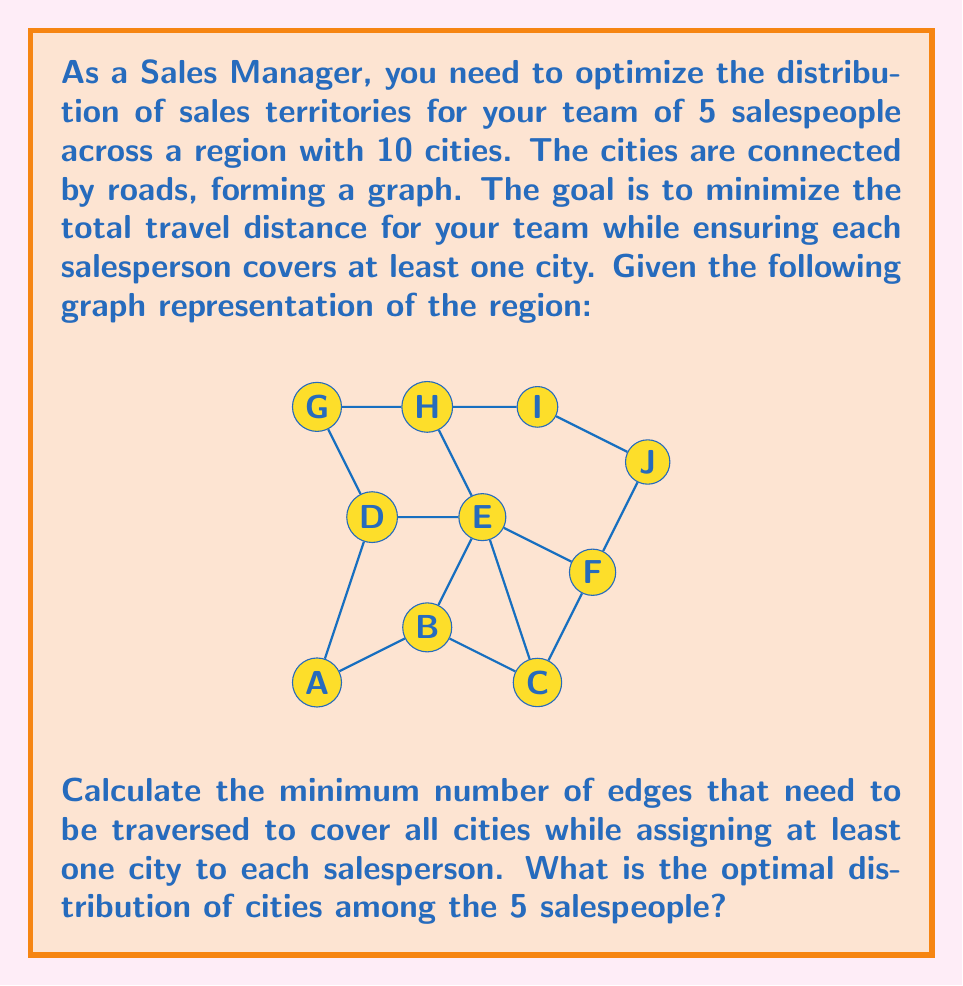Could you help me with this problem? To solve this problem, we'll use concepts from graph theory, specifically the minimum spanning tree (MST) algorithm and graph partitioning.

Step 1: Find the Minimum Spanning Tree
First, we need to find the MST of the given graph to minimize the total travel distance. We can use Kruskal's or Prim's algorithm for this. The MST will have 9 edges (number of vertices - 1).

Step 2: Count the edges in the MST
The number of edges in the MST is 9, which represents the minimum number of edges that need to be traversed to cover all cities.

Step 3: Partition the MST
To distribute the cities among 5 salespeople, we need to partition the MST into 5 connected components. This can be done by removing 4 edges (number of salespeople - 1) from the MST.

Step 4: Choose edges to remove
We want to remove edges that create balanced partitions. By inspection, we can remove the following edges:
1. Edge between B and E
2. Edge between E and F
3. Edge between F and J
4. Edge between D and G

Step 5: Assign territories
After removing these edges, we get 5 connected components that can be assigned to the salespeople:
1. Salesperson 1: A, B
2. Salesperson 2: C, E
3. Salesperson 3: D, G, H
4. Salesperson 4: F
5. Salesperson 5: I, J

This distribution ensures that each salesperson covers at least one city and minimizes the total travel distance within each territory.
Answer: 9 edges; Distribution: {A,B}, {C,E}, {D,G,H}, {F}, {I,J} 